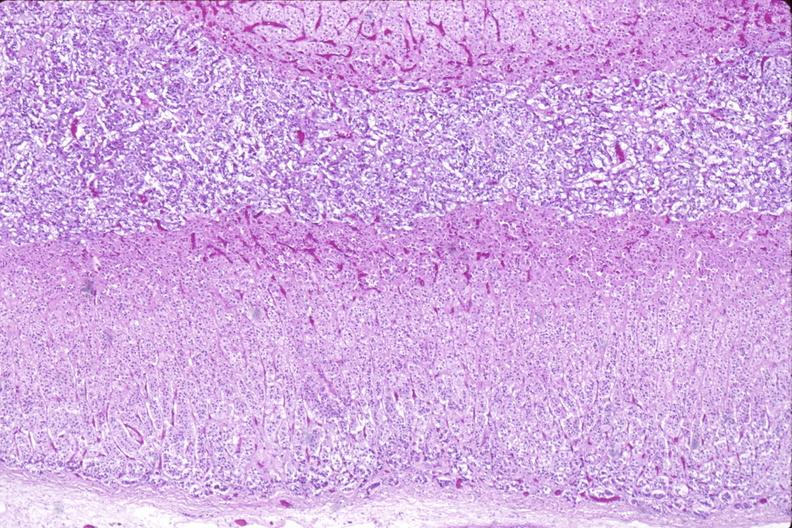does this image show adrenal gland, normal histology?
Answer the question using a single word or phrase. Yes 